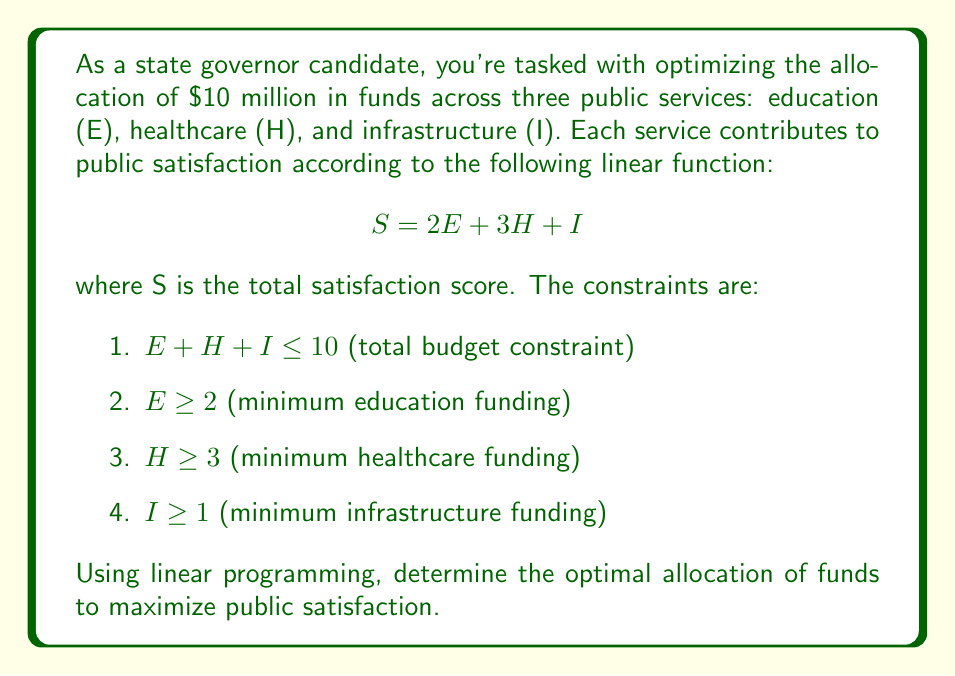Provide a solution to this math problem. To solve this linear programming problem, we'll use the simplex method:

1. Define the objective function:
   Maximize $S = 2E + 3H + I$

2. List the constraints:
   $E + H + I \leq 10$
   $E \geq 2$
   $H \geq 3$
   $I \geq 1$

3. Convert to standard form by introducing slack variables:
   Maximize $S = 2E + 3H + I$
   Subject to:
   $E + H + I + s_1 = 10$
   $E - s_2 = 2$
   $H - s_3 = 3$
   $I - s_4 = 1$
   $E, H, I, s_1, s_2, s_3, s_4 \geq 0$

4. Create the initial tableau:
   $$
   \begin{array}{c|cccc|cccc|c}
   & E & H & I & S & s_1 & s_2 & s_3 & s_4 & RHS \\
   \hline
   S & -2 & -3 & -1 & 1 & 0 & 0 & 0 & 0 & 0 \\
   s_1 & 1 & 1 & 1 & 0 & 1 & 0 & 0 & 0 & 10 \\
   s_2 & 1 & 0 & 0 & 0 & 0 & -1 & 0 & 0 & 2 \\
   s_3 & 0 & 1 & 0 & 0 & 0 & 0 & -1 & 0 & 3 \\
   s_4 & 0 & 0 & 1 & 0 & 0 & 0 & 0 & -1 & 1 \\
   \end{array}
   $$

5. Perform pivot operations to improve the solution:
   - Choose H as the entering variable (most negative in objective row)
   - Choose s_1 as the leaving variable (smallest ratio: 10/1 = 10)

6. After pivoting, we get:
   $$
   \begin{array}{c|cccc|cccc|c}
   & E & H & I & S & s_1 & s_2 & s_3 & s_4 & RHS \\
   \hline
   S & -2/3 & 0 & 2/3 & 1 & 1 & 0 & 0 & 0 & 30 \\
   H & 1/3 & 1 & 1/3 & 0 & 1/3 & 0 & 0 & 0 & 10/3 \\
   s_2 & 1 & 0 & 0 & 0 & 0 & -1 & 0 & 0 & 2 \\
   s_3 & -1/3 & 0 & -1/3 & 0 & -1/3 & 0 & -1 & 0 & 1/3 \\
   s_4 & 0 & 0 & 1 & 0 & 0 & 0 & 0 & -1 & 1 \\
   \end{array}
   $$

7. The optimal solution is reached as there are no negative values in the objective row.

8. Read the solution:
   $E = 2$ (from s_2 row)
   $H = 10/3 \approx 3.33$
   $I = 1$ (from s_4 row)

9. Calculate the maximum satisfaction:
   $S = 2(2) + 3(10/3) + 1 = 4 + 10 + 1 = 15$
Answer: $E = 2$, $H = 10/3$, $I = 1$; Maximum satisfaction: 15 